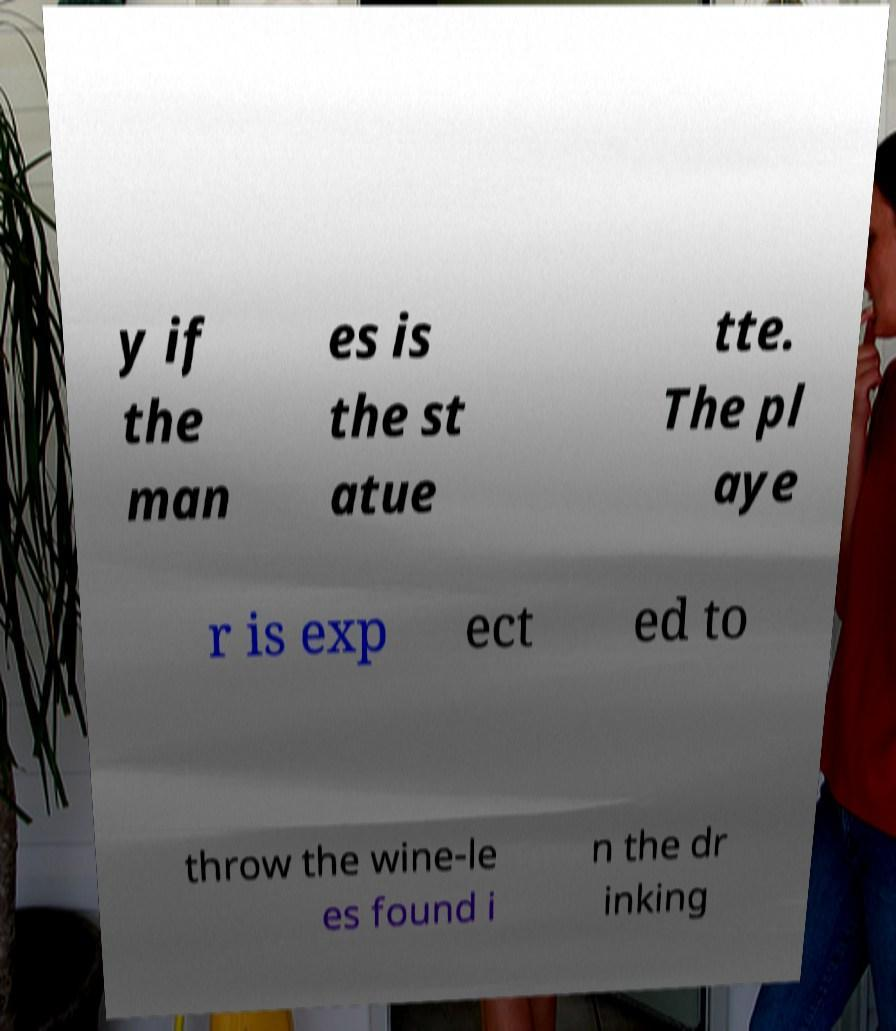There's text embedded in this image that I need extracted. Can you transcribe it verbatim? y if the man es is the st atue tte. The pl aye r is exp ect ed to throw the wine-le es found i n the dr inking 